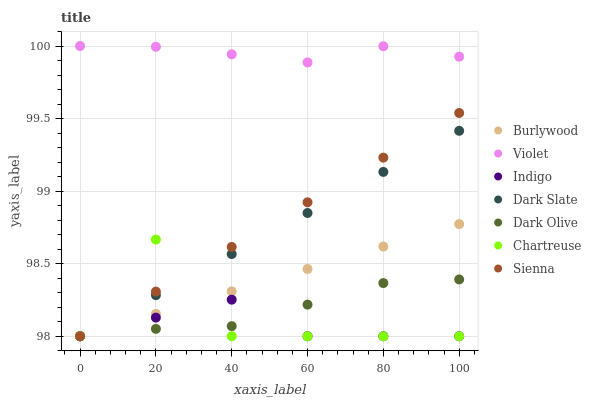Does Indigo have the minimum area under the curve?
Answer yes or no. Yes. Does Violet have the maximum area under the curve?
Answer yes or no. Yes. Does Burlywood have the minimum area under the curve?
Answer yes or no. No. Does Burlywood have the maximum area under the curve?
Answer yes or no. No. Is Sienna the smoothest?
Answer yes or no. Yes. Is Chartreuse the roughest?
Answer yes or no. Yes. Is Burlywood the smoothest?
Answer yes or no. No. Is Burlywood the roughest?
Answer yes or no. No. Does Indigo have the lowest value?
Answer yes or no. Yes. Does Violet have the lowest value?
Answer yes or no. No. Does Violet have the highest value?
Answer yes or no. Yes. Does Burlywood have the highest value?
Answer yes or no. No. Is Sienna less than Violet?
Answer yes or no. Yes. Is Violet greater than Indigo?
Answer yes or no. Yes. Does Dark Slate intersect Indigo?
Answer yes or no. Yes. Is Dark Slate less than Indigo?
Answer yes or no. No. Is Dark Slate greater than Indigo?
Answer yes or no. No. Does Sienna intersect Violet?
Answer yes or no. No. 